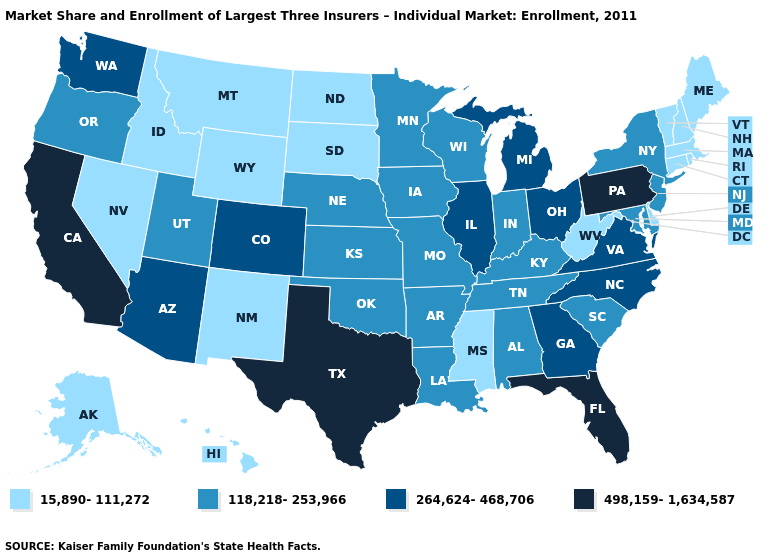What is the lowest value in the West?
Be succinct. 15,890-111,272. Does Massachusetts have a lower value than Washington?
Short answer required. Yes. What is the value of Illinois?
Quick response, please. 264,624-468,706. Does West Virginia have the lowest value in the South?
Be succinct. Yes. What is the value of Indiana?
Short answer required. 118,218-253,966. Does Texas have the highest value in the USA?
Quick response, please. Yes. What is the highest value in the West ?
Be succinct. 498,159-1,634,587. Name the states that have a value in the range 264,624-468,706?
Be succinct. Arizona, Colorado, Georgia, Illinois, Michigan, North Carolina, Ohio, Virginia, Washington. What is the value of Vermont?
Concise answer only. 15,890-111,272. Does Oregon have the same value as Washington?
Answer briefly. No. Does Texas have a higher value than Montana?
Keep it brief. Yes. Name the states that have a value in the range 15,890-111,272?
Short answer required. Alaska, Connecticut, Delaware, Hawaii, Idaho, Maine, Massachusetts, Mississippi, Montana, Nevada, New Hampshire, New Mexico, North Dakota, Rhode Island, South Dakota, Vermont, West Virginia, Wyoming. What is the value of North Carolina?
Keep it brief. 264,624-468,706. What is the highest value in the USA?
Concise answer only. 498,159-1,634,587. Does the first symbol in the legend represent the smallest category?
Answer briefly. Yes. 